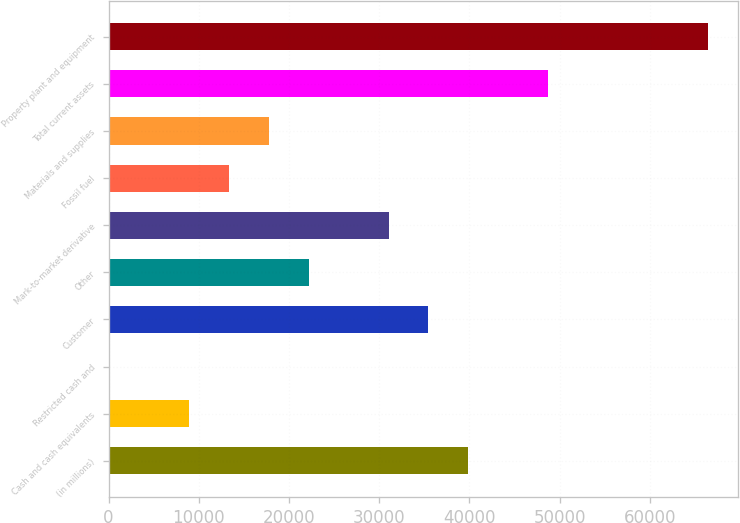<chart> <loc_0><loc_0><loc_500><loc_500><bar_chart><fcel>(in millions)<fcel>Cash and cash equivalents<fcel>Restricted cash and<fcel>Customer<fcel>Other<fcel>Mark-to-market derivative<fcel>Fossil fuel<fcel>Materials and supplies<fcel>Total current assets<fcel>Property plant and equipment<nl><fcel>39892.9<fcel>8910.2<fcel>58<fcel>35466.8<fcel>22188.5<fcel>31040.7<fcel>13336.3<fcel>17762.4<fcel>48745.1<fcel>66449.5<nl></chart> 